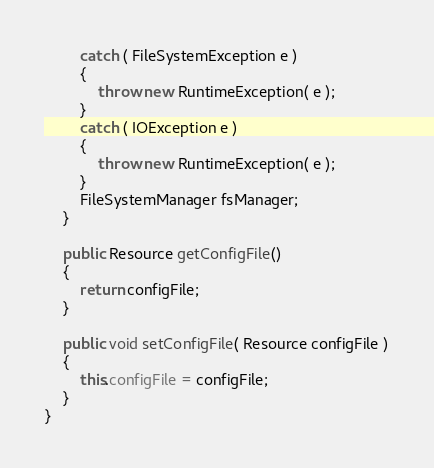Convert code to text. <code><loc_0><loc_0><loc_500><loc_500><_Java_>		catch ( FileSystemException e )
		{
			throw new RuntimeException( e );
		}
		catch ( IOException e )
		{
			throw new RuntimeException( e );
		}
		FileSystemManager fsManager;
	}

	public Resource getConfigFile()
	{
		return configFile;
	}

	public void setConfigFile( Resource configFile )
	{
		this.configFile = configFile;
	}
}

</code> 